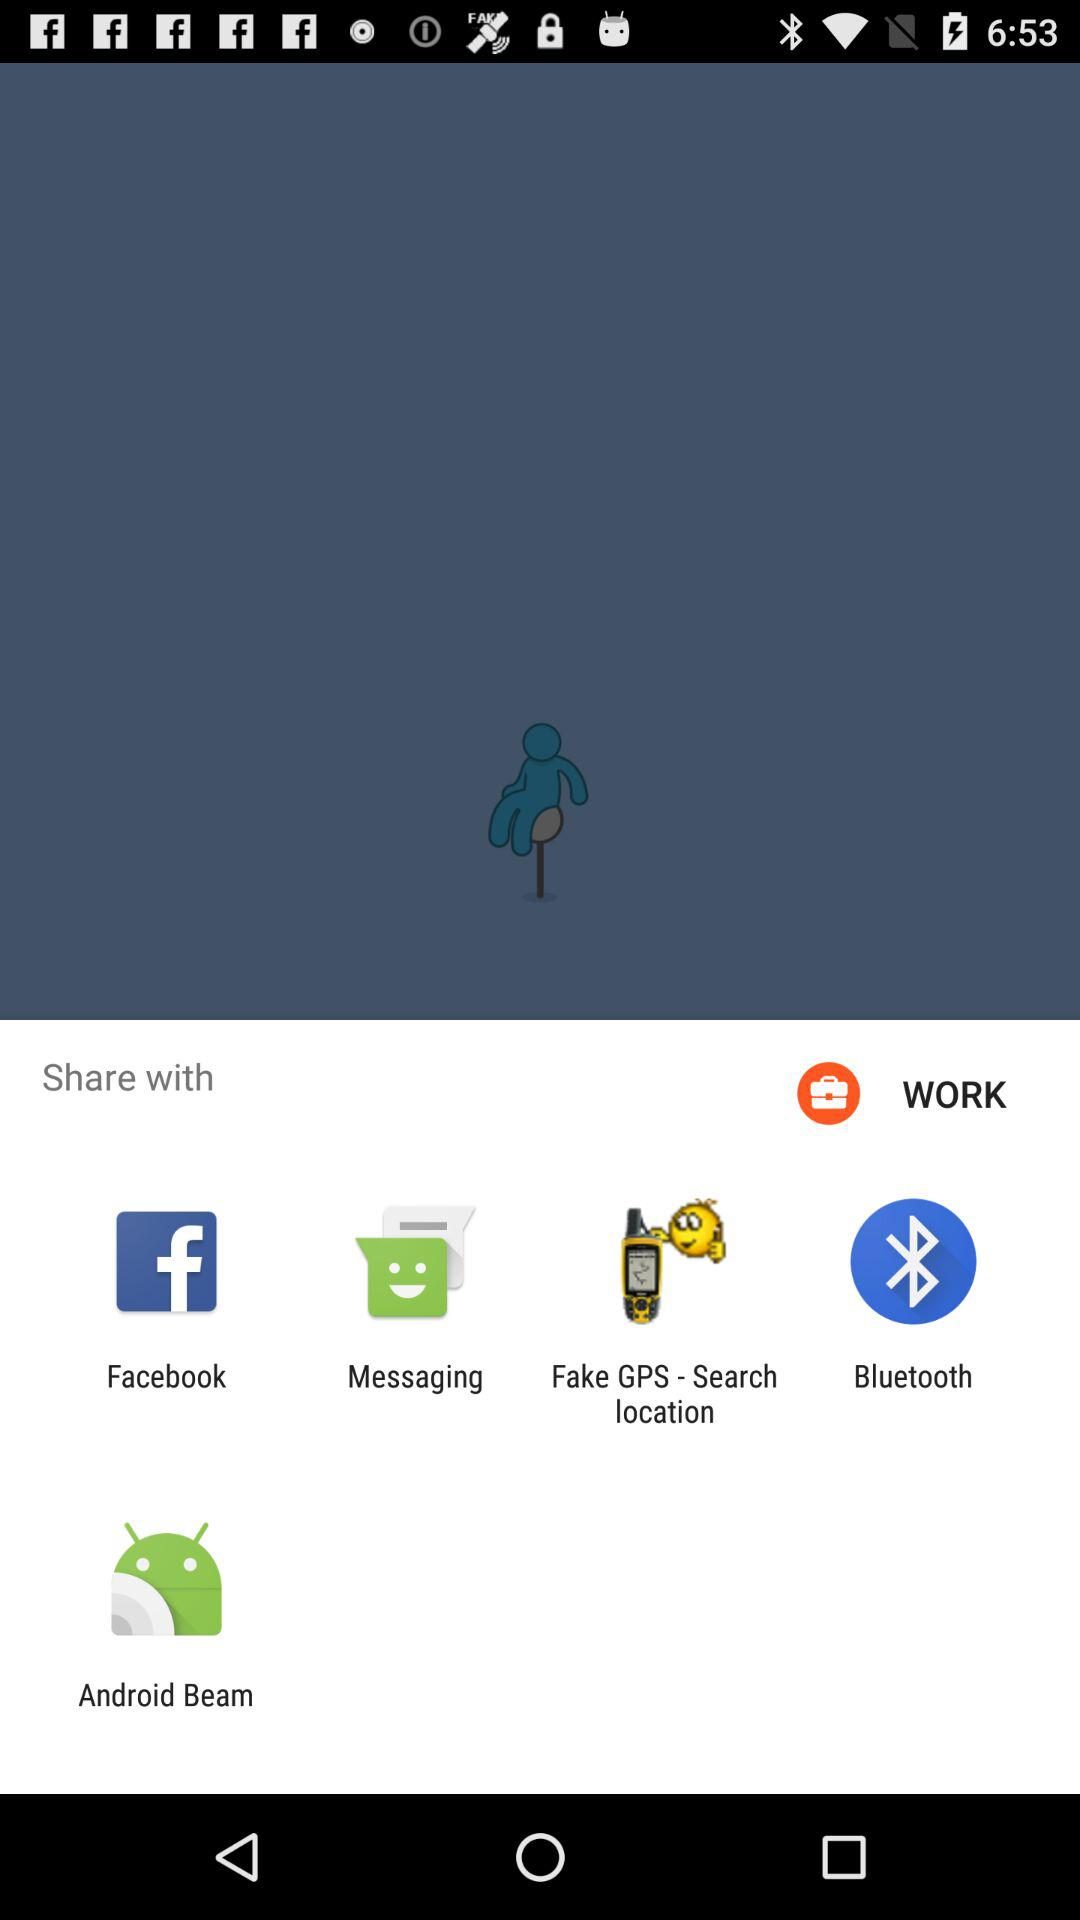Who is sharing this content?
When the provided information is insufficient, respond with <no answer>. <no answer> 